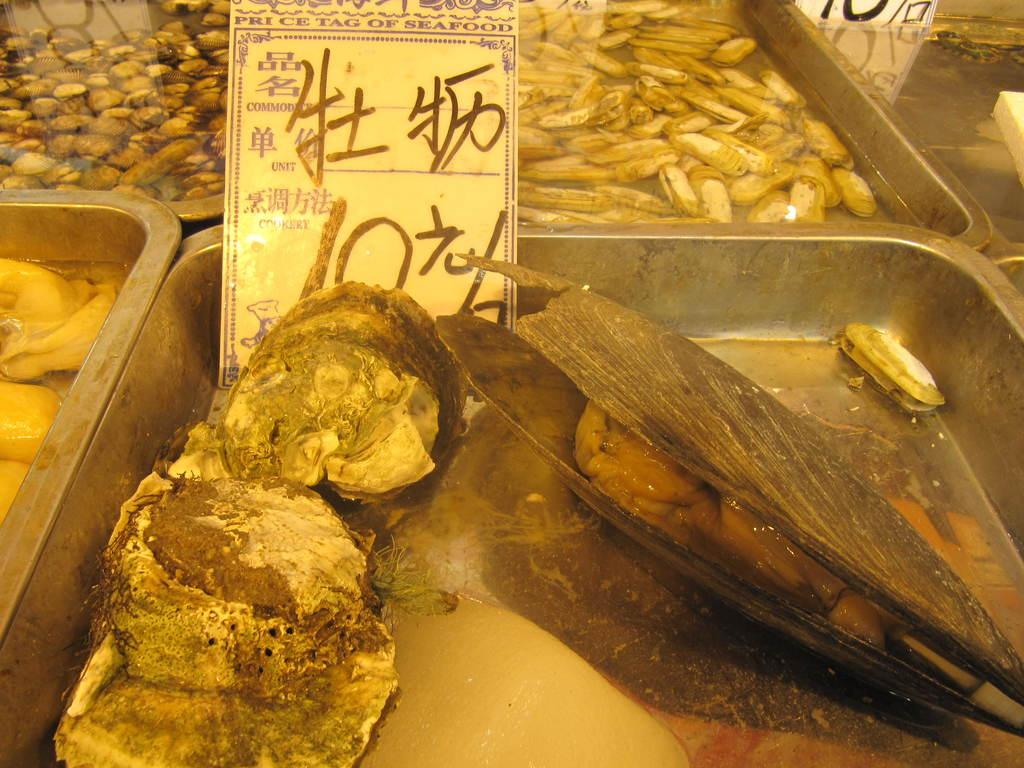What objects are present in the image that can hold food? There are bowls in the image that can hold food. What is inside the bowls? There is food in the bowls. What additional element can be seen in the image? There is a banner in the image. Can you tell me how many trees are depicted on the banner in the image? There are no trees depicted on the banner in the image. 